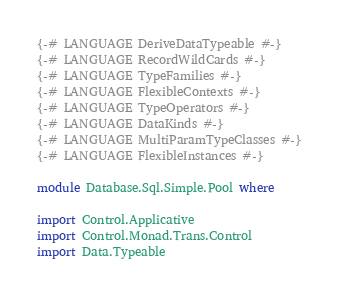<code> <loc_0><loc_0><loc_500><loc_500><_Haskell_>{-# LANGUAGE DeriveDataTypeable #-}
{-# LANGUAGE RecordWildCards #-}
{-# LANGUAGE TypeFamilies #-}
{-# LANGUAGE FlexibleContexts #-}
{-# LANGUAGE TypeOperators #-}
{-# LANGUAGE DataKinds #-}
{-# LANGUAGE MultiParamTypeClasses #-}
{-# LANGUAGE FlexibleInstances #-}

module Database.Sql.Simple.Pool where

import Control.Applicative
import Control.Monad.Trans.Control
import Data.Typeable</code> 